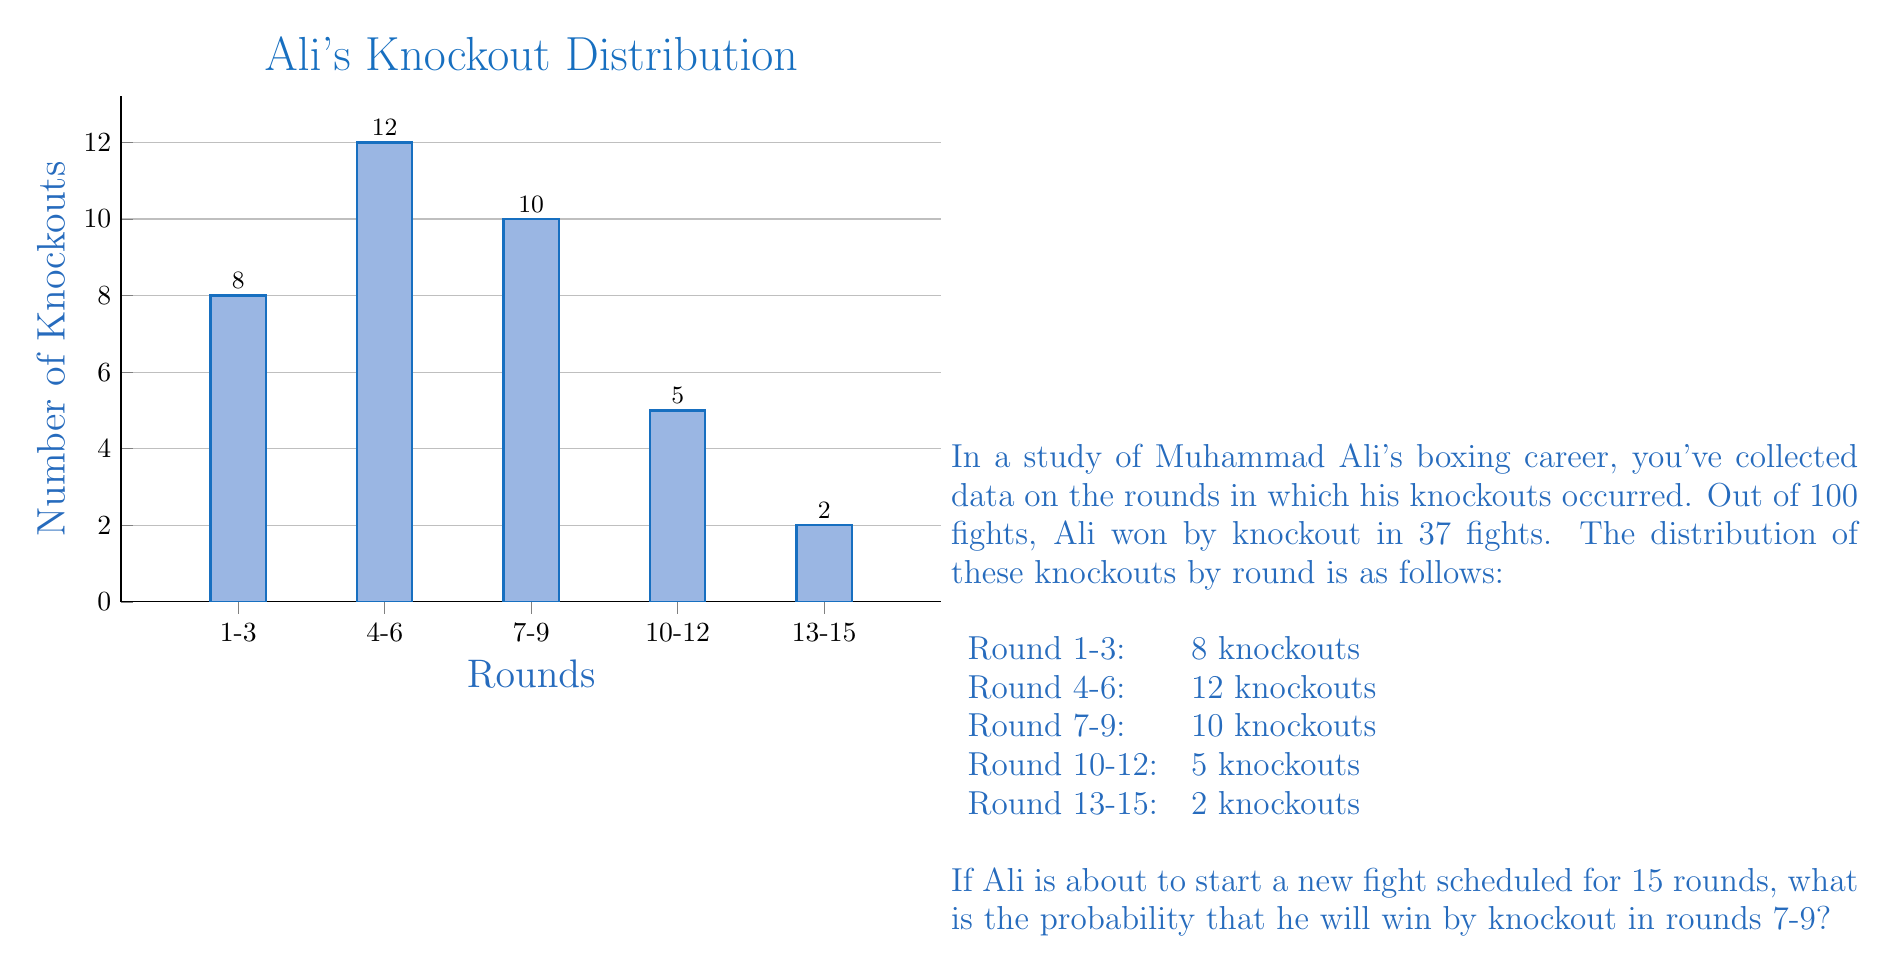Give your solution to this math problem. To solve this problem, we need to use the concept of conditional probability. We're looking for the probability of a knockout occurring in rounds 7-9, given that a knockout occurs at all.

Step 1: Calculate the total number of knockouts.
Total knockouts = 8 + 12 + 10 + 5 + 2 = 37

Step 2: Calculate the probability of a knockout occurring in any round.
P(Knockout) = 37 / 100 = 0.37

Step 3: Calculate the probability of a knockout occurring in rounds 7-9, given that a knockout occurs.
P(Round 7-9 | Knockout) = 10 / 37

Step 4: Calculate the probability of a knockout occurring in rounds 7-9 for the new fight.
We use the multiplication rule of probability:

P(Knockout in Round 7-9) = P(Knockout) × P(Round 7-9 | Knockout)

$$ P(\text{Knockout in Round 7-9}) = 0.37 \times \frac{10}{37} = \frac{0.37 \times 10}{37} = \frac{3.7}{37} = 0.1 $$

Therefore, the probability that Ali will win by knockout in rounds 7-9 in the new fight is 0.1 or 10%.
Answer: 0.1 